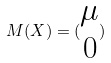Convert formula to latex. <formula><loc_0><loc_0><loc_500><loc_500>M ( X ) = ( \begin{matrix} \mu \\ 0 \\ \end{matrix} )</formula> 